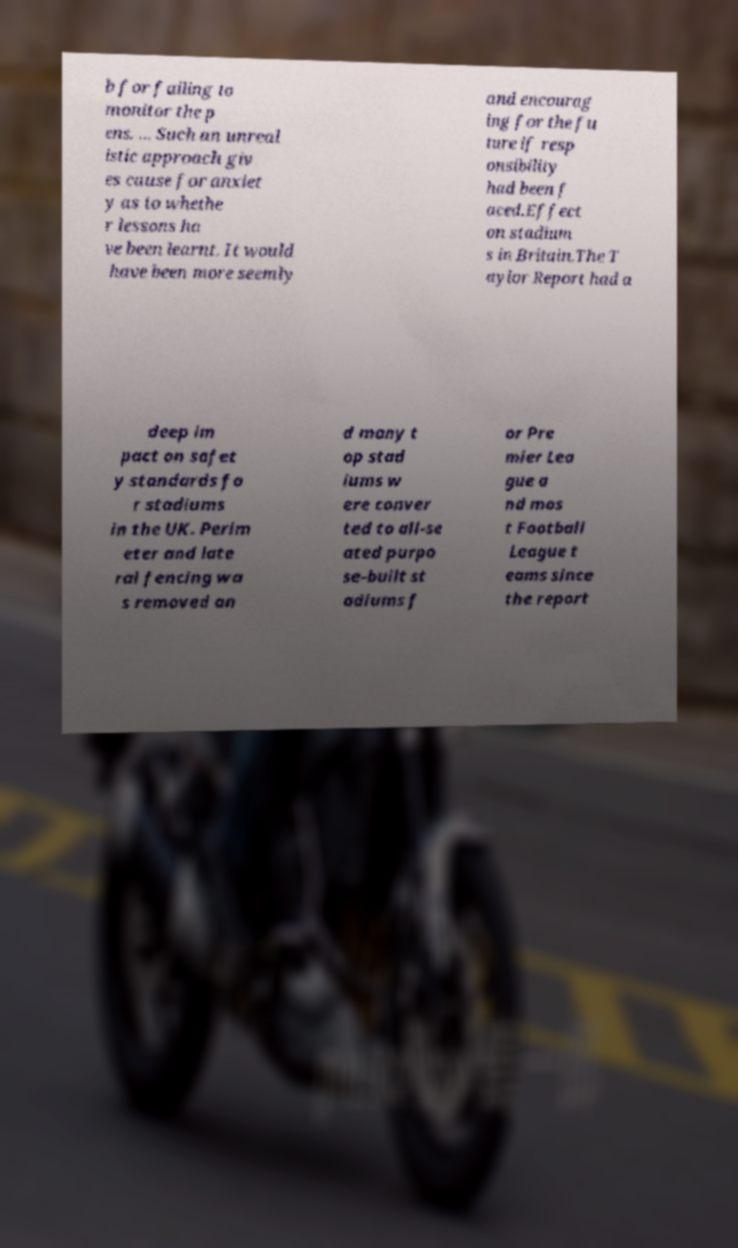Please read and relay the text visible in this image. What does it say? b for failing to monitor the p ens. ... Such an unreal istic approach giv es cause for anxiet y as to whethe r lessons ha ve been learnt. It would have been more seemly and encourag ing for the fu ture if resp onsibility had been f aced.Effect on stadium s in Britain.The T aylor Report had a deep im pact on safet y standards fo r stadiums in the UK. Perim eter and late ral fencing wa s removed an d many t op stad iums w ere conver ted to all-se ated purpo se-built st adiums f or Pre mier Lea gue a nd mos t Football League t eams since the report 